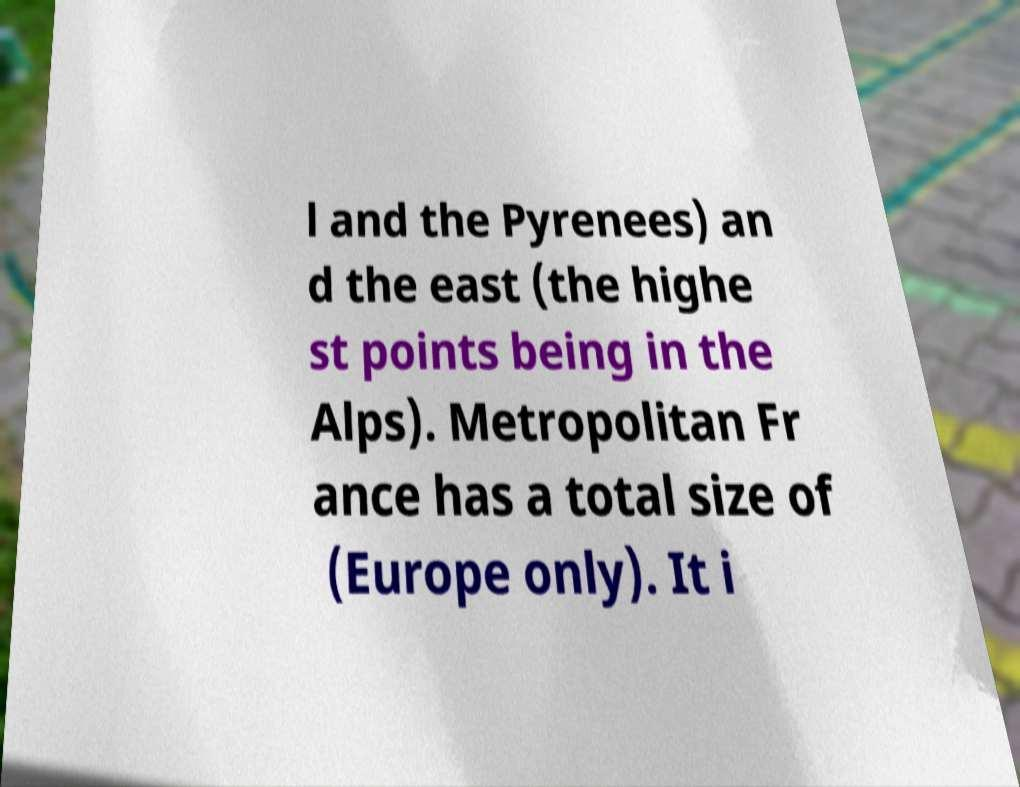Can you read and provide the text displayed in the image?This photo seems to have some interesting text. Can you extract and type it out for me? l and the Pyrenees) an d the east (the highe st points being in the Alps). Metropolitan Fr ance has a total size of (Europe only). It i 